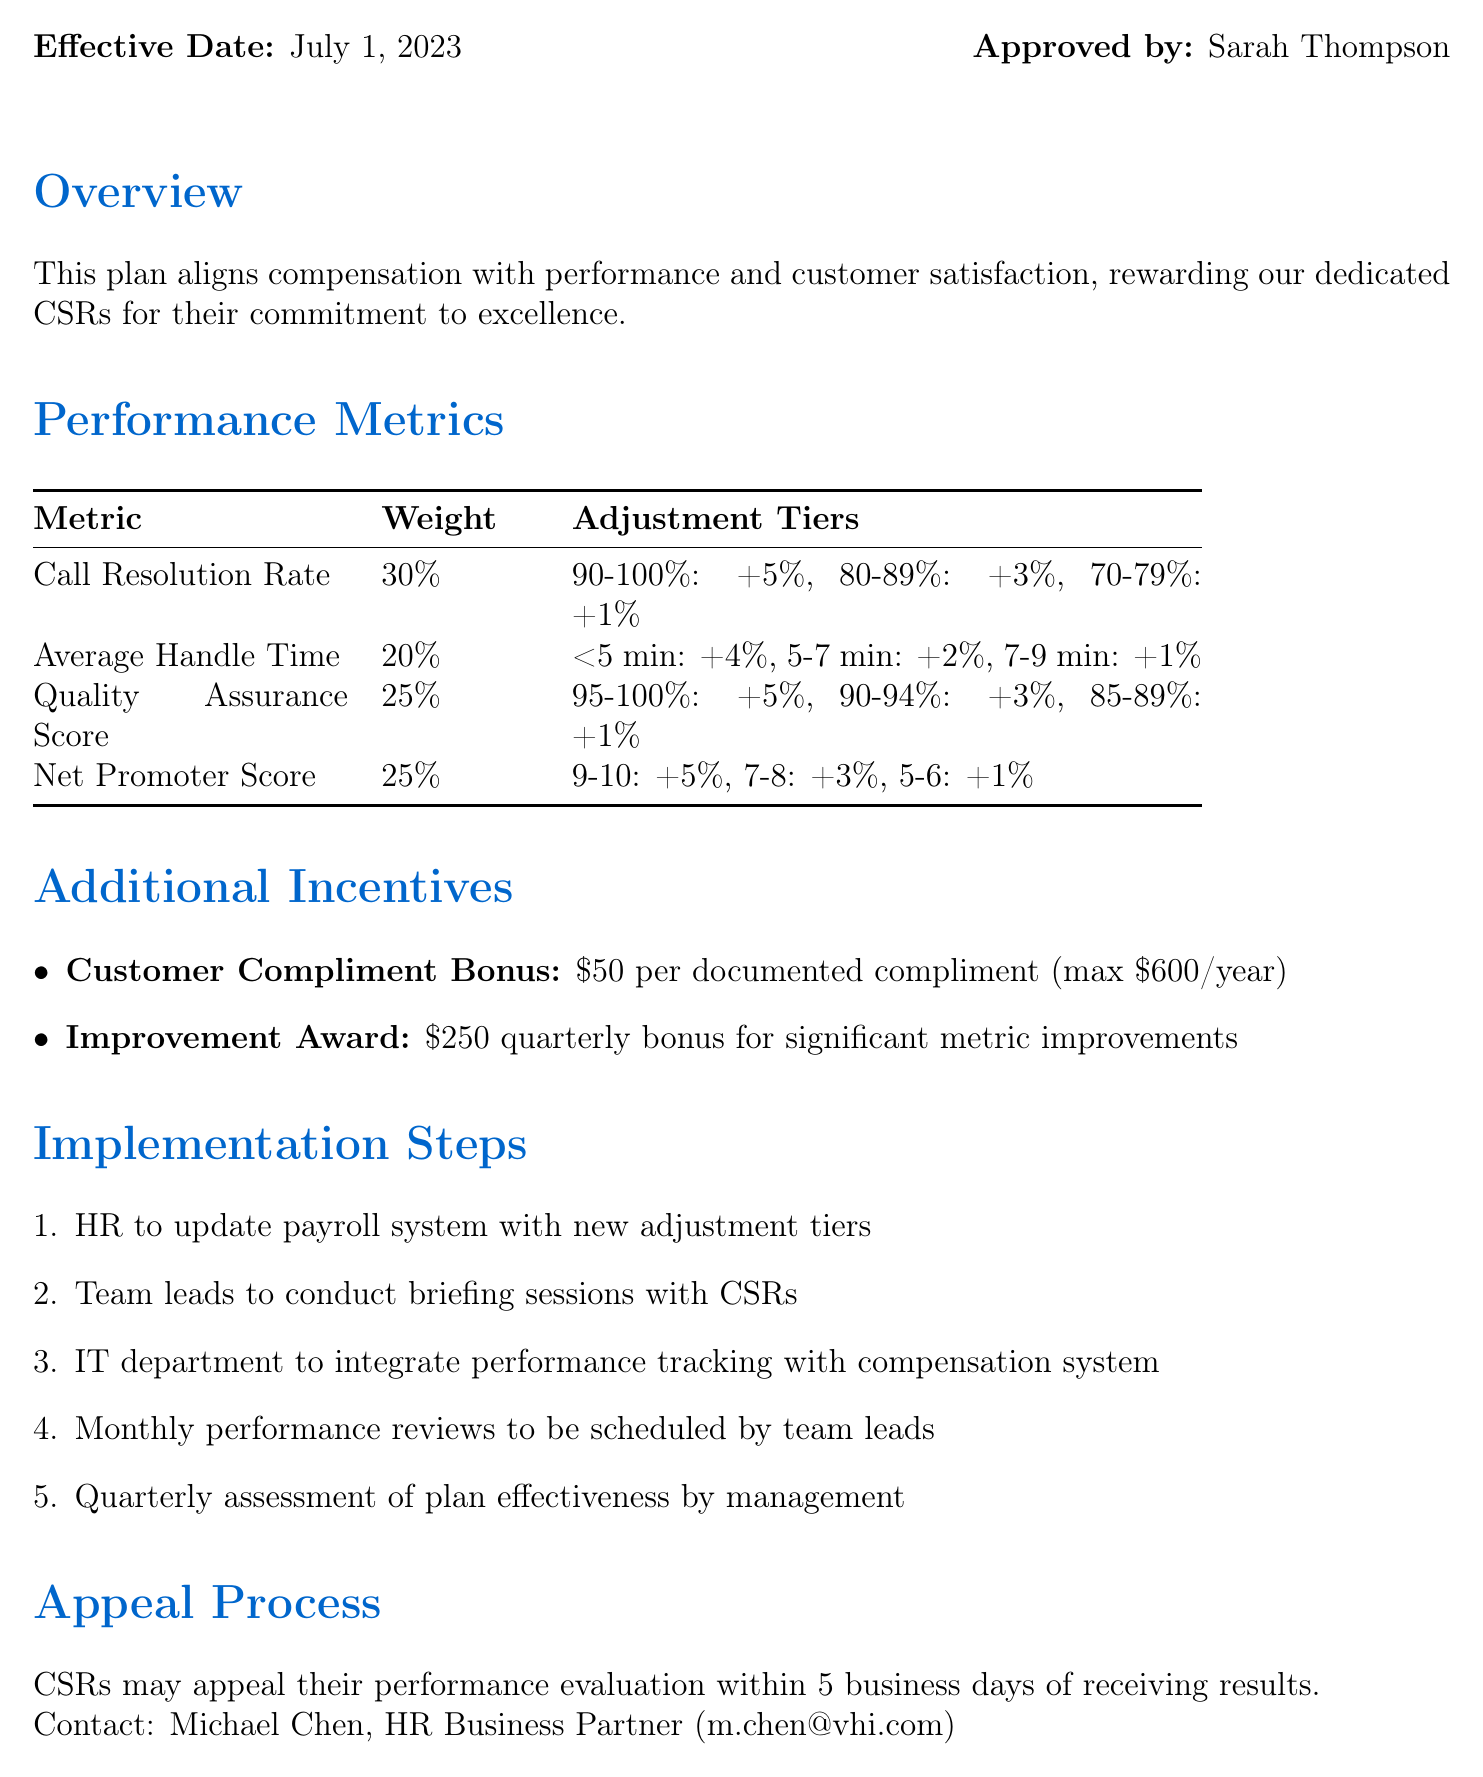What is the title of the plan? The title of the plan is stated at the beginning of the document, which specifically mentions its purpose for customer service representatives.
Answer: VHI Customer Service Representative Compensation Adjustment Plan Who approved the compensation adjustment plan? The document mentions who approved the plan, indicating the responsible authority in VHI.
Answer: Sarah Thompson What is the effective date of the plan? The effective date is mentioned clearly, indicating when the plan starts to take effect.
Answer: July 1, 2023 What is the weight of the Call Resolution Rate metric? The weightings of each performance metric are provided in a tabular format, specifically for Call Resolution Rate.
Answer: 30 What is the maximum annual amount for the Customer Compliment Bonus? The document specifies the financial cap for this additional incentive, providing a clear monetary value.
Answer: $600 How many tiers are there for the Quality Assurance Score? The adjustment tiers for the Quality Assurance Score can be counted from the information provided in the performance metrics section.
Answer: 3 What bonus do CSRs receive for showing significant improvement? The document outlines specific bonuses for improvement, indicating the reward for enhanced performance.
Answer: $250 What is the appeal process for CSRs? The document details the procedure under which CSRs can appeal their evaluations, including a timeframe for filing an appeal.
Answer: Within 5 business days Who should CSRs contact for appeals? The document provides the name and contact information of the individual responsible for handling appeals.
Answer: Michael Chen 